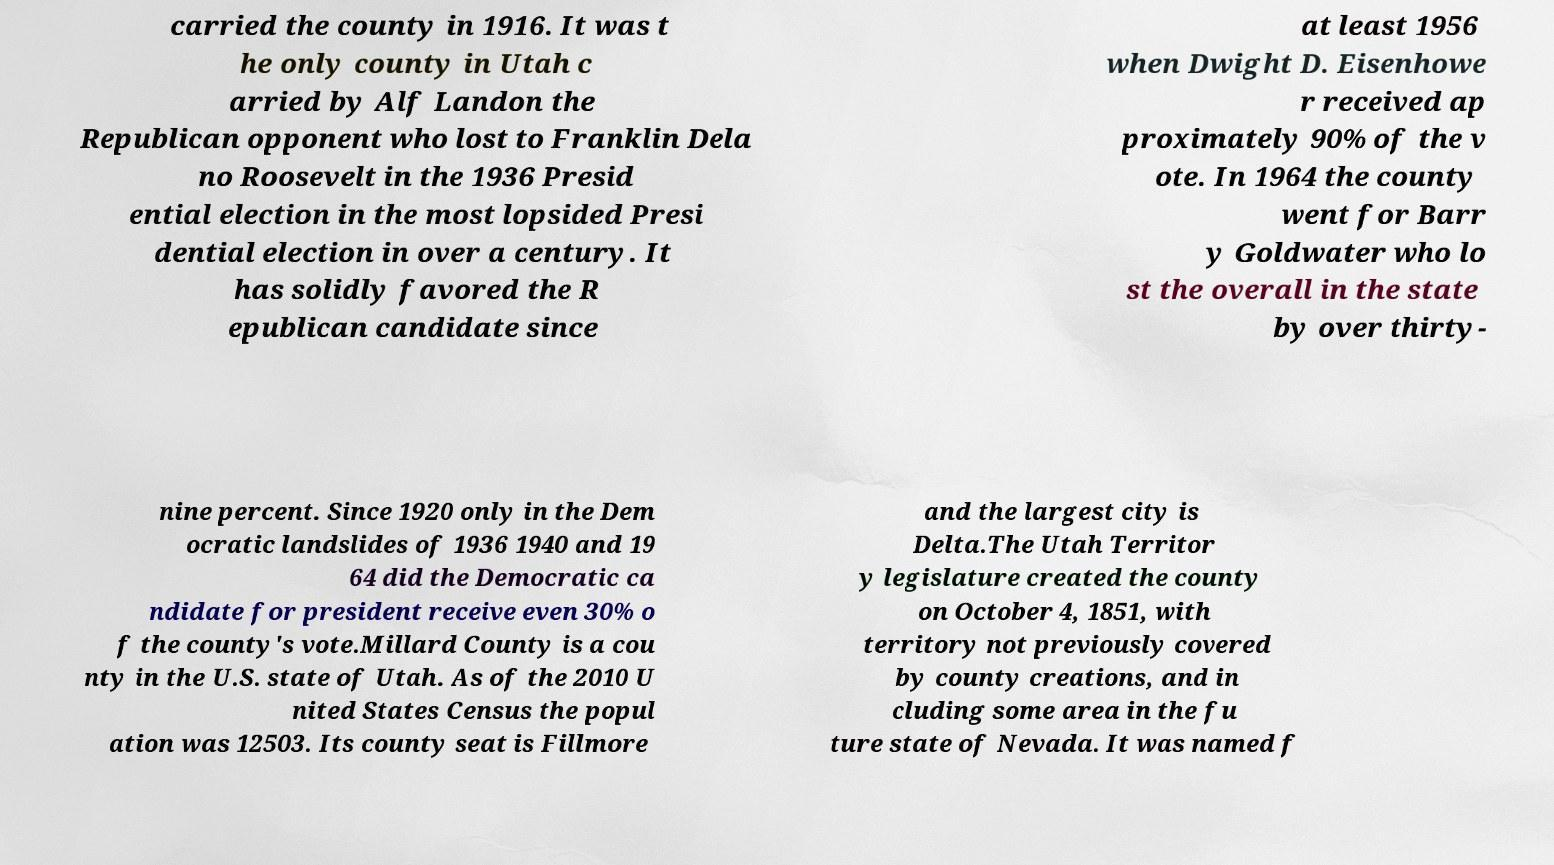For documentation purposes, I need the text within this image transcribed. Could you provide that? carried the county in 1916. It was t he only county in Utah c arried by Alf Landon the Republican opponent who lost to Franklin Dela no Roosevelt in the 1936 Presid ential election in the most lopsided Presi dential election in over a century. It has solidly favored the R epublican candidate since at least 1956 when Dwight D. Eisenhowe r received ap proximately 90% of the v ote. In 1964 the county went for Barr y Goldwater who lo st the overall in the state by over thirty- nine percent. Since 1920 only in the Dem ocratic landslides of 1936 1940 and 19 64 did the Democratic ca ndidate for president receive even 30% o f the county's vote.Millard County is a cou nty in the U.S. state of Utah. As of the 2010 U nited States Census the popul ation was 12503. Its county seat is Fillmore and the largest city is Delta.The Utah Territor y legislature created the county on October 4, 1851, with territory not previously covered by county creations, and in cluding some area in the fu ture state of Nevada. It was named f 